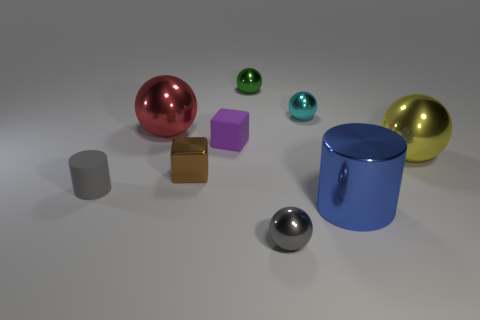Subtract 1 balls. How many balls are left? 4 Subtract all cyan balls. How many balls are left? 4 Subtract all yellow metal spheres. How many spheres are left? 4 Subtract all gray balls. Subtract all purple blocks. How many balls are left? 4 Add 1 spheres. How many objects exist? 10 Subtract all cylinders. How many objects are left? 7 Add 4 small gray rubber cylinders. How many small gray rubber cylinders are left? 5 Add 6 gray cylinders. How many gray cylinders exist? 7 Subtract 0 blue spheres. How many objects are left? 9 Subtract all purple rubber objects. Subtract all gray things. How many objects are left? 6 